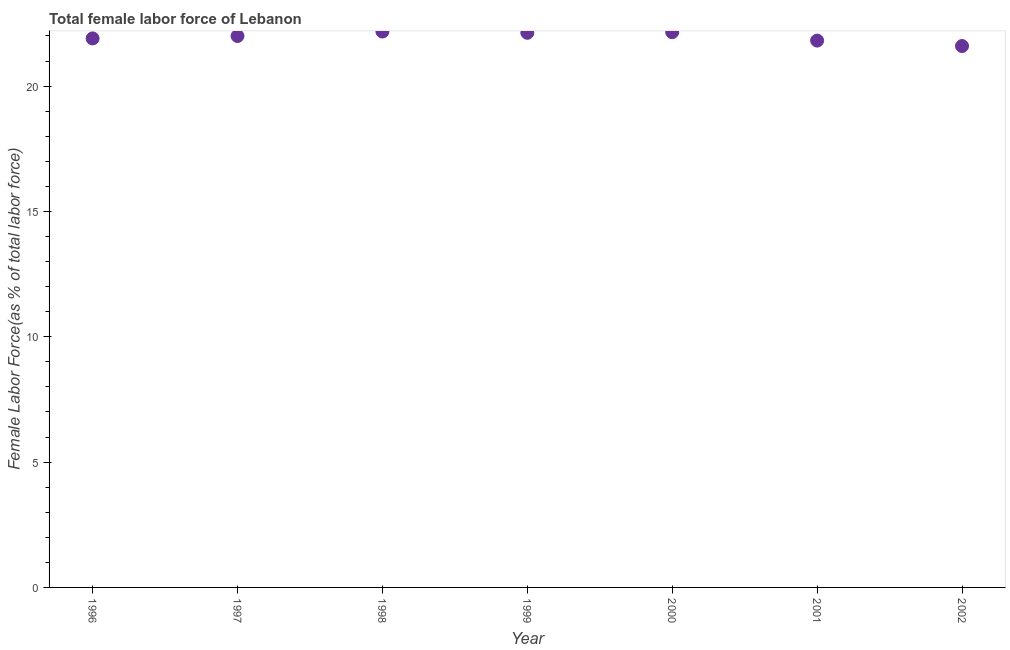What is the total female labor force in 2001?
Your answer should be compact. 21.82. Across all years, what is the maximum total female labor force?
Provide a short and direct response. 22.18. Across all years, what is the minimum total female labor force?
Provide a succinct answer. 21.6. In which year was the total female labor force maximum?
Your answer should be very brief. 1998. In which year was the total female labor force minimum?
Offer a terse response. 2002. What is the sum of the total female labor force?
Ensure brevity in your answer.  153.76. What is the difference between the total female labor force in 1997 and 2000?
Make the answer very short. -0.15. What is the average total female labor force per year?
Make the answer very short. 21.97. What is the median total female labor force?
Provide a short and direct response. 22. Do a majority of the years between 1998 and 2000 (inclusive) have total female labor force greater than 13 %?
Offer a very short reply. Yes. What is the ratio of the total female labor force in 1997 to that in 1998?
Your answer should be very brief. 0.99. Is the total female labor force in 2000 less than that in 2001?
Provide a short and direct response. No. Is the difference between the total female labor force in 1998 and 2000 greater than the difference between any two years?
Make the answer very short. No. What is the difference between the highest and the second highest total female labor force?
Keep it short and to the point. 0.03. Is the sum of the total female labor force in 2000 and 2002 greater than the maximum total female labor force across all years?
Your answer should be compact. Yes. What is the difference between the highest and the lowest total female labor force?
Provide a short and direct response. 0.58. How many years are there in the graph?
Provide a short and direct response. 7. What is the difference between two consecutive major ticks on the Y-axis?
Ensure brevity in your answer.  5. Are the values on the major ticks of Y-axis written in scientific E-notation?
Your answer should be compact. No. Does the graph contain grids?
Give a very brief answer. No. What is the title of the graph?
Ensure brevity in your answer.  Total female labor force of Lebanon. What is the label or title of the X-axis?
Make the answer very short. Year. What is the label or title of the Y-axis?
Ensure brevity in your answer.  Female Labor Force(as % of total labor force). What is the Female Labor Force(as % of total labor force) in 1996?
Provide a succinct answer. 21.9. What is the Female Labor Force(as % of total labor force) in 1997?
Give a very brief answer. 22. What is the Female Labor Force(as % of total labor force) in 1998?
Ensure brevity in your answer.  22.18. What is the Female Labor Force(as % of total labor force) in 1999?
Provide a succinct answer. 22.13. What is the Female Labor Force(as % of total labor force) in 2000?
Your answer should be very brief. 22.15. What is the Female Labor Force(as % of total labor force) in 2001?
Offer a terse response. 21.82. What is the Female Labor Force(as % of total labor force) in 2002?
Give a very brief answer. 21.6. What is the difference between the Female Labor Force(as % of total labor force) in 1996 and 1997?
Your answer should be very brief. -0.1. What is the difference between the Female Labor Force(as % of total labor force) in 1996 and 1998?
Give a very brief answer. -0.27. What is the difference between the Female Labor Force(as % of total labor force) in 1996 and 1999?
Offer a terse response. -0.22. What is the difference between the Female Labor Force(as % of total labor force) in 1996 and 2000?
Ensure brevity in your answer.  -0.25. What is the difference between the Female Labor Force(as % of total labor force) in 1996 and 2001?
Offer a very short reply. 0.09. What is the difference between the Female Labor Force(as % of total labor force) in 1996 and 2002?
Offer a terse response. 0.3. What is the difference between the Female Labor Force(as % of total labor force) in 1997 and 1998?
Your answer should be very brief. -0.18. What is the difference between the Female Labor Force(as % of total labor force) in 1997 and 1999?
Make the answer very short. -0.13. What is the difference between the Female Labor Force(as % of total labor force) in 1997 and 2000?
Provide a succinct answer. -0.15. What is the difference between the Female Labor Force(as % of total labor force) in 1997 and 2001?
Ensure brevity in your answer.  0.18. What is the difference between the Female Labor Force(as % of total labor force) in 1997 and 2002?
Offer a very short reply. 0.4. What is the difference between the Female Labor Force(as % of total labor force) in 1998 and 1999?
Your answer should be compact. 0.05. What is the difference between the Female Labor Force(as % of total labor force) in 1998 and 2000?
Offer a very short reply. 0.03. What is the difference between the Female Labor Force(as % of total labor force) in 1998 and 2001?
Offer a terse response. 0.36. What is the difference between the Female Labor Force(as % of total labor force) in 1998 and 2002?
Give a very brief answer. 0.58. What is the difference between the Female Labor Force(as % of total labor force) in 1999 and 2000?
Keep it short and to the point. -0.02. What is the difference between the Female Labor Force(as % of total labor force) in 1999 and 2001?
Your answer should be very brief. 0.31. What is the difference between the Female Labor Force(as % of total labor force) in 1999 and 2002?
Provide a succinct answer. 0.53. What is the difference between the Female Labor Force(as % of total labor force) in 2000 and 2001?
Your answer should be very brief. 0.33. What is the difference between the Female Labor Force(as % of total labor force) in 2000 and 2002?
Your answer should be very brief. 0.55. What is the difference between the Female Labor Force(as % of total labor force) in 2001 and 2002?
Ensure brevity in your answer.  0.22. What is the ratio of the Female Labor Force(as % of total labor force) in 1996 to that in 1997?
Ensure brevity in your answer.  1. What is the ratio of the Female Labor Force(as % of total labor force) in 1996 to that in 1998?
Provide a succinct answer. 0.99. What is the ratio of the Female Labor Force(as % of total labor force) in 1996 to that in 2002?
Make the answer very short. 1.01. What is the ratio of the Female Labor Force(as % of total labor force) in 1997 to that in 1998?
Offer a very short reply. 0.99. What is the ratio of the Female Labor Force(as % of total labor force) in 1997 to that in 2001?
Provide a short and direct response. 1.01. What is the ratio of the Female Labor Force(as % of total labor force) in 1998 to that in 1999?
Offer a very short reply. 1. What is the ratio of the Female Labor Force(as % of total labor force) in 1998 to that in 2000?
Your response must be concise. 1. What is the ratio of the Female Labor Force(as % of total labor force) in 1998 to that in 2001?
Keep it short and to the point. 1.02. What is the ratio of the Female Labor Force(as % of total labor force) in 1999 to that in 2000?
Offer a terse response. 1. What is the ratio of the Female Labor Force(as % of total labor force) in 1999 to that in 2001?
Your answer should be compact. 1.01. What is the ratio of the Female Labor Force(as % of total labor force) in 1999 to that in 2002?
Your answer should be very brief. 1.02. What is the ratio of the Female Labor Force(as % of total labor force) in 2000 to that in 2002?
Offer a very short reply. 1.03. What is the ratio of the Female Labor Force(as % of total labor force) in 2001 to that in 2002?
Your answer should be compact. 1.01. 